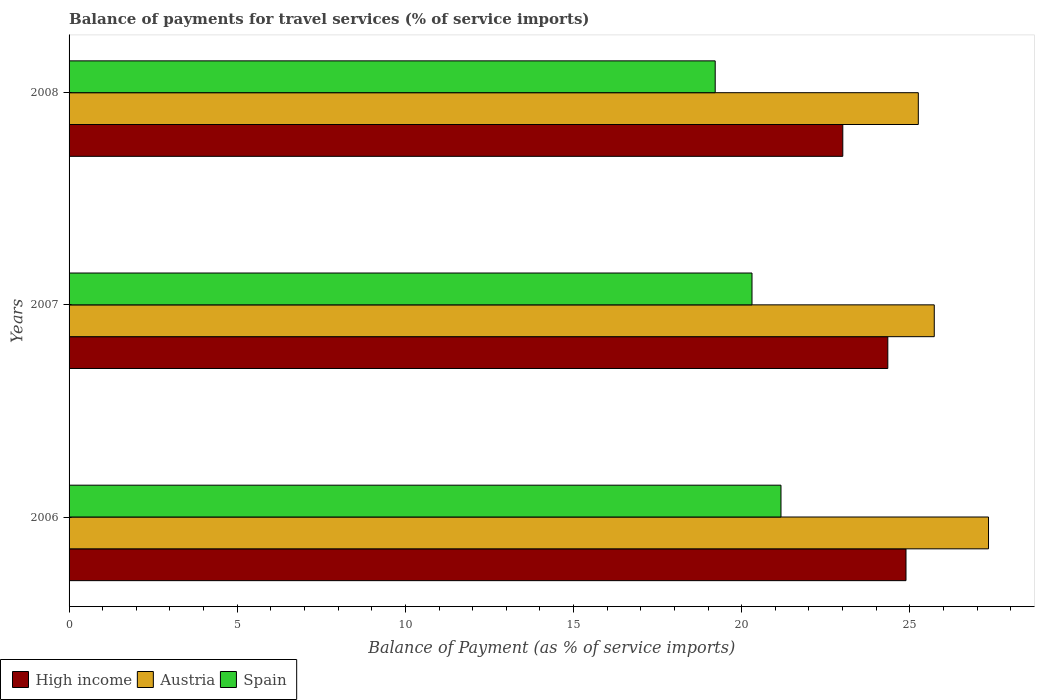How many groups of bars are there?
Your answer should be very brief. 3. Are the number of bars per tick equal to the number of legend labels?
Your answer should be very brief. Yes. What is the label of the 3rd group of bars from the top?
Offer a very short reply. 2006. What is the balance of payments for travel services in Spain in 2008?
Offer a very short reply. 19.21. Across all years, what is the maximum balance of payments for travel services in High income?
Your answer should be compact. 24.89. Across all years, what is the minimum balance of payments for travel services in Austria?
Ensure brevity in your answer.  25.25. In which year was the balance of payments for travel services in High income minimum?
Keep it short and to the point. 2008. What is the total balance of payments for travel services in Austria in the graph?
Provide a succinct answer. 78.32. What is the difference between the balance of payments for travel services in Spain in 2007 and that in 2008?
Make the answer very short. 1.09. What is the difference between the balance of payments for travel services in Spain in 2008 and the balance of payments for travel services in High income in 2007?
Offer a very short reply. -5.13. What is the average balance of payments for travel services in Austria per year?
Provide a succinct answer. 26.11. In the year 2007, what is the difference between the balance of payments for travel services in High income and balance of payments for travel services in Spain?
Ensure brevity in your answer.  4.04. What is the ratio of the balance of payments for travel services in High income in 2006 to that in 2008?
Make the answer very short. 1.08. Is the balance of payments for travel services in Austria in 2007 less than that in 2008?
Make the answer very short. No. What is the difference between the highest and the second highest balance of payments for travel services in Austria?
Give a very brief answer. 1.61. What is the difference between the highest and the lowest balance of payments for travel services in High income?
Offer a very short reply. 1.88. Is the sum of the balance of payments for travel services in Spain in 2006 and 2008 greater than the maximum balance of payments for travel services in High income across all years?
Ensure brevity in your answer.  Yes. What does the 3rd bar from the top in 2006 represents?
Your answer should be compact. High income. Is it the case that in every year, the sum of the balance of payments for travel services in High income and balance of payments for travel services in Spain is greater than the balance of payments for travel services in Austria?
Your response must be concise. Yes. How many bars are there?
Your answer should be very brief. 9. What is the difference between two consecutive major ticks on the X-axis?
Give a very brief answer. 5. Does the graph contain grids?
Give a very brief answer. No. How are the legend labels stacked?
Your answer should be very brief. Horizontal. What is the title of the graph?
Your answer should be very brief. Balance of payments for travel services (% of service imports). What is the label or title of the X-axis?
Ensure brevity in your answer.  Balance of Payment (as % of service imports). What is the Balance of Payment (as % of service imports) of High income in 2006?
Ensure brevity in your answer.  24.89. What is the Balance of Payment (as % of service imports) of Austria in 2006?
Give a very brief answer. 27.34. What is the Balance of Payment (as % of service imports) in Spain in 2006?
Your answer should be compact. 21.17. What is the Balance of Payment (as % of service imports) in High income in 2007?
Provide a short and direct response. 24.34. What is the Balance of Payment (as % of service imports) in Austria in 2007?
Offer a very short reply. 25.73. What is the Balance of Payment (as % of service imports) in Spain in 2007?
Offer a terse response. 20.31. What is the Balance of Payment (as % of service imports) in High income in 2008?
Your response must be concise. 23.01. What is the Balance of Payment (as % of service imports) in Austria in 2008?
Offer a very short reply. 25.25. What is the Balance of Payment (as % of service imports) of Spain in 2008?
Your response must be concise. 19.21. Across all years, what is the maximum Balance of Payment (as % of service imports) in High income?
Your answer should be compact. 24.89. Across all years, what is the maximum Balance of Payment (as % of service imports) in Austria?
Your answer should be compact. 27.34. Across all years, what is the maximum Balance of Payment (as % of service imports) of Spain?
Give a very brief answer. 21.17. Across all years, what is the minimum Balance of Payment (as % of service imports) of High income?
Provide a short and direct response. 23.01. Across all years, what is the minimum Balance of Payment (as % of service imports) of Austria?
Provide a succinct answer. 25.25. Across all years, what is the minimum Balance of Payment (as % of service imports) of Spain?
Provide a succinct answer. 19.21. What is the total Balance of Payment (as % of service imports) in High income in the graph?
Ensure brevity in your answer.  72.24. What is the total Balance of Payment (as % of service imports) in Austria in the graph?
Make the answer very short. 78.32. What is the total Balance of Payment (as % of service imports) of Spain in the graph?
Your answer should be compact. 60.69. What is the difference between the Balance of Payment (as % of service imports) in High income in 2006 and that in 2007?
Your answer should be very brief. 0.54. What is the difference between the Balance of Payment (as % of service imports) in Austria in 2006 and that in 2007?
Your answer should be compact. 1.61. What is the difference between the Balance of Payment (as % of service imports) of Spain in 2006 and that in 2007?
Offer a terse response. 0.86. What is the difference between the Balance of Payment (as % of service imports) of High income in 2006 and that in 2008?
Give a very brief answer. 1.88. What is the difference between the Balance of Payment (as % of service imports) in Austria in 2006 and that in 2008?
Provide a succinct answer. 2.09. What is the difference between the Balance of Payment (as % of service imports) of Spain in 2006 and that in 2008?
Provide a succinct answer. 1.96. What is the difference between the Balance of Payment (as % of service imports) in High income in 2007 and that in 2008?
Provide a short and direct response. 1.34. What is the difference between the Balance of Payment (as % of service imports) of Austria in 2007 and that in 2008?
Keep it short and to the point. 0.47. What is the difference between the Balance of Payment (as % of service imports) of Spain in 2007 and that in 2008?
Give a very brief answer. 1.09. What is the difference between the Balance of Payment (as % of service imports) in High income in 2006 and the Balance of Payment (as % of service imports) in Austria in 2007?
Provide a short and direct response. -0.84. What is the difference between the Balance of Payment (as % of service imports) in High income in 2006 and the Balance of Payment (as % of service imports) in Spain in 2007?
Your answer should be very brief. 4.58. What is the difference between the Balance of Payment (as % of service imports) of Austria in 2006 and the Balance of Payment (as % of service imports) of Spain in 2007?
Make the answer very short. 7.03. What is the difference between the Balance of Payment (as % of service imports) in High income in 2006 and the Balance of Payment (as % of service imports) in Austria in 2008?
Your response must be concise. -0.37. What is the difference between the Balance of Payment (as % of service imports) in High income in 2006 and the Balance of Payment (as % of service imports) in Spain in 2008?
Keep it short and to the point. 5.67. What is the difference between the Balance of Payment (as % of service imports) of Austria in 2006 and the Balance of Payment (as % of service imports) of Spain in 2008?
Keep it short and to the point. 8.13. What is the difference between the Balance of Payment (as % of service imports) in High income in 2007 and the Balance of Payment (as % of service imports) in Austria in 2008?
Provide a short and direct response. -0.91. What is the difference between the Balance of Payment (as % of service imports) in High income in 2007 and the Balance of Payment (as % of service imports) in Spain in 2008?
Your response must be concise. 5.13. What is the difference between the Balance of Payment (as % of service imports) of Austria in 2007 and the Balance of Payment (as % of service imports) of Spain in 2008?
Your answer should be very brief. 6.51. What is the average Balance of Payment (as % of service imports) in High income per year?
Ensure brevity in your answer.  24.08. What is the average Balance of Payment (as % of service imports) of Austria per year?
Your answer should be very brief. 26.11. What is the average Balance of Payment (as % of service imports) of Spain per year?
Provide a succinct answer. 20.23. In the year 2006, what is the difference between the Balance of Payment (as % of service imports) in High income and Balance of Payment (as % of service imports) in Austria?
Keep it short and to the point. -2.45. In the year 2006, what is the difference between the Balance of Payment (as % of service imports) of High income and Balance of Payment (as % of service imports) of Spain?
Give a very brief answer. 3.72. In the year 2006, what is the difference between the Balance of Payment (as % of service imports) of Austria and Balance of Payment (as % of service imports) of Spain?
Provide a succinct answer. 6.17. In the year 2007, what is the difference between the Balance of Payment (as % of service imports) in High income and Balance of Payment (as % of service imports) in Austria?
Offer a very short reply. -1.38. In the year 2007, what is the difference between the Balance of Payment (as % of service imports) in High income and Balance of Payment (as % of service imports) in Spain?
Give a very brief answer. 4.04. In the year 2007, what is the difference between the Balance of Payment (as % of service imports) of Austria and Balance of Payment (as % of service imports) of Spain?
Offer a terse response. 5.42. In the year 2008, what is the difference between the Balance of Payment (as % of service imports) in High income and Balance of Payment (as % of service imports) in Austria?
Keep it short and to the point. -2.25. In the year 2008, what is the difference between the Balance of Payment (as % of service imports) of High income and Balance of Payment (as % of service imports) of Spain?
Keep it short and to the point. 3.79. In the year 2008, what is the difference between the Balance of Payment (as % of service imports) in Austria and Balance of Payment (as % of service imports) in Spain?
Make the answer very short. 6.04. What is the ratio of the Balance of Payment (as % of service imports) in High income in 2006 to that in 2007?
Ensure brevity in your answer.  1.02. What is the ratio of the Balance of Payment (as % of service imports) of Austria in 2006 to that in 2007?
Provide a short and direct response. 1.06. What is the ratio of the Balance of Payment (as % of service imports) in Spain in 2006 to that in 2007?
Ensure brevity in your answer.  1.04. What is the ratio of the Balance of Payment (as % of service imports) of High income in 2006 to that in 2008?
Keep it short and to the point. 1.08. What is the ratio of the Balance of Payment (as % of service imports) in Austria in 2006 to that in 2008?
Give a very brief answer. 1.08. What is the ratio of the Balance of Payment (as % of service imports) of Spain in 2006 to that in 2008?
Your answer should be compact. 1.1. What is the ratio of the Balance of Payment (as % of service imports) of High income in 2007 to that in 2008?
Offer a very short reply. 1.06. What is the ratio of the Balance of Payment (as % of service imports) in Austria in 2007 to that in 2008?
Provide a succinct answer. 1.02. What is the ratio of the Balance of Payment (as % of service imports) of Spain in 2007 to that in 2008?
Give a very brief answer. 1.06. What is the difference between the highest and the second highest Balance of Payment (as % of service imports) of High income?
Your response must be concise. 0.54. What is the difference between the highest and the second highest Balance of Payment (as % of service imports) in Austria?
Ensure brevity in your answer.  1.61. What is the difference between the highest and the second highest Balance of Payment (as % of service imports) of Spain?
Keep it short and to the point. 0.86. What is the difference between the highest and the lowest Balance of Payment (as % of service imports) of High income?
Your answer should be very brief. 1.88. What is the difference between the highest and the lowest Balance of Payment (as % of service imports) in Austria?
Ensure brevity in your answer.  2.09. What is the difference between the highest and the lowest Balance of Payment (as % of service imports) in Spain?
Offer a very short reply. 1.96. 